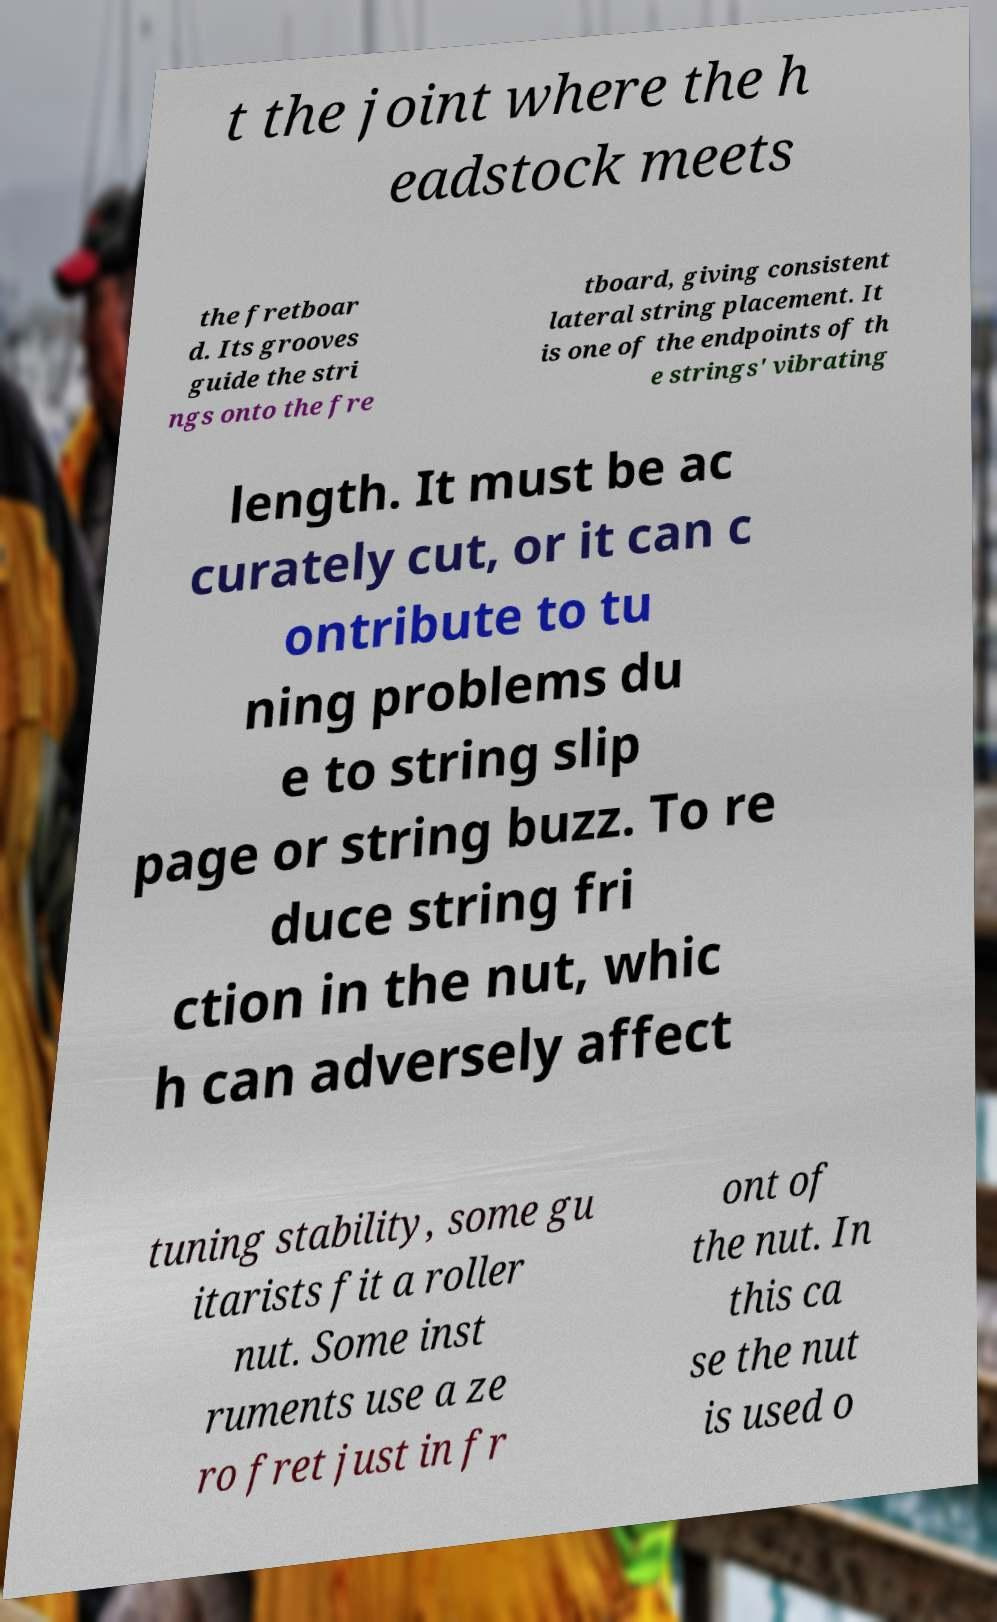Can you accurately transcribe the text from the provided image for me? t the joint where the h eadstock meets the fretboar d. Its grooves guide the stri ngs onto the fre tboard, giving consistent lateral string placement. It is one of the endpoints of th e strings' vibrating length. It must be ac curately cut, or it can c ontribute to tu ning problems du e to string slip page or string buzz. To re duce string fri ction in the nut, whic h can adversely affect tuning stability, some gu itarists fit a roller nut. Some inst ruments use a ze ro fret just in fr ont of the nut. In this ca se the nut is used o 